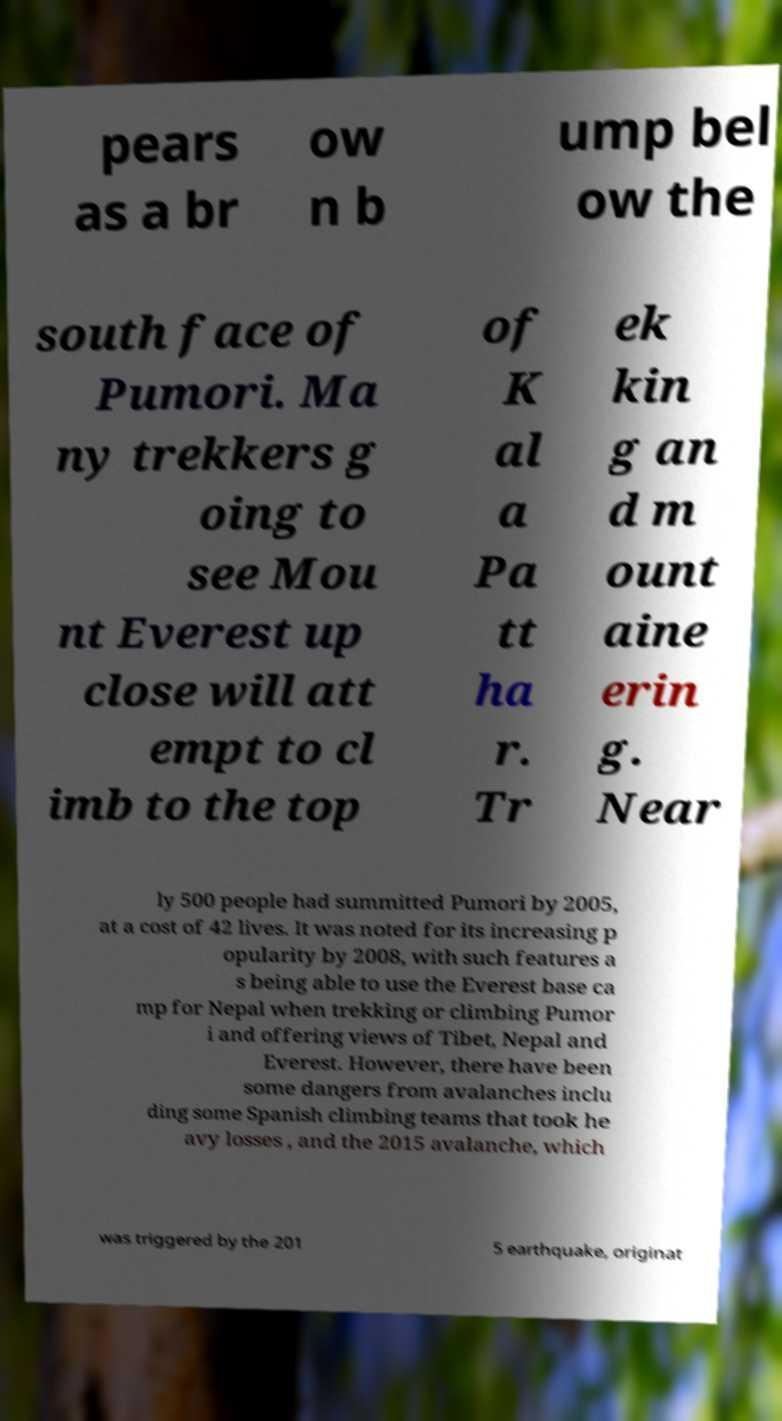I need the written content from this picture converted into text. Can you do that? pears as a br ow n b ump bel ow the south face of Pumori. Ma ny trekkers g oing to see Mou nt Everest up close will att empt to cl imb to the top of K al a Pa tt ha r. Tr ek kin g an d m ount aine erin g. Near ly 500 people had summitted Pumori by 2005, at a cost of 42 lives. It was noted for its increasing p opularity by 2008, with such features a s being able to use the Everest base ca mp for Nepal when trekking or climbing Pumor i and offering views of Tibet, Nepal and Everest. However, there have been some dangers from avalanches inclu ding some Spanish climbing teams that took he avy losses , and the 2015 avalanche, which was triggered by the 201 5 earthquake, originat 